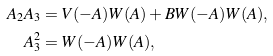<formula> <loc_0><loc_0><loc_500><loc_500>A _ { 2 } A _ { 3 } & = V ( - A ) W ( A ) + B W ( - A ) W ( A ) , \\ A _ { 3 } ^ { 2 } & = W ( - A ) W ( A ) ,</formula> 